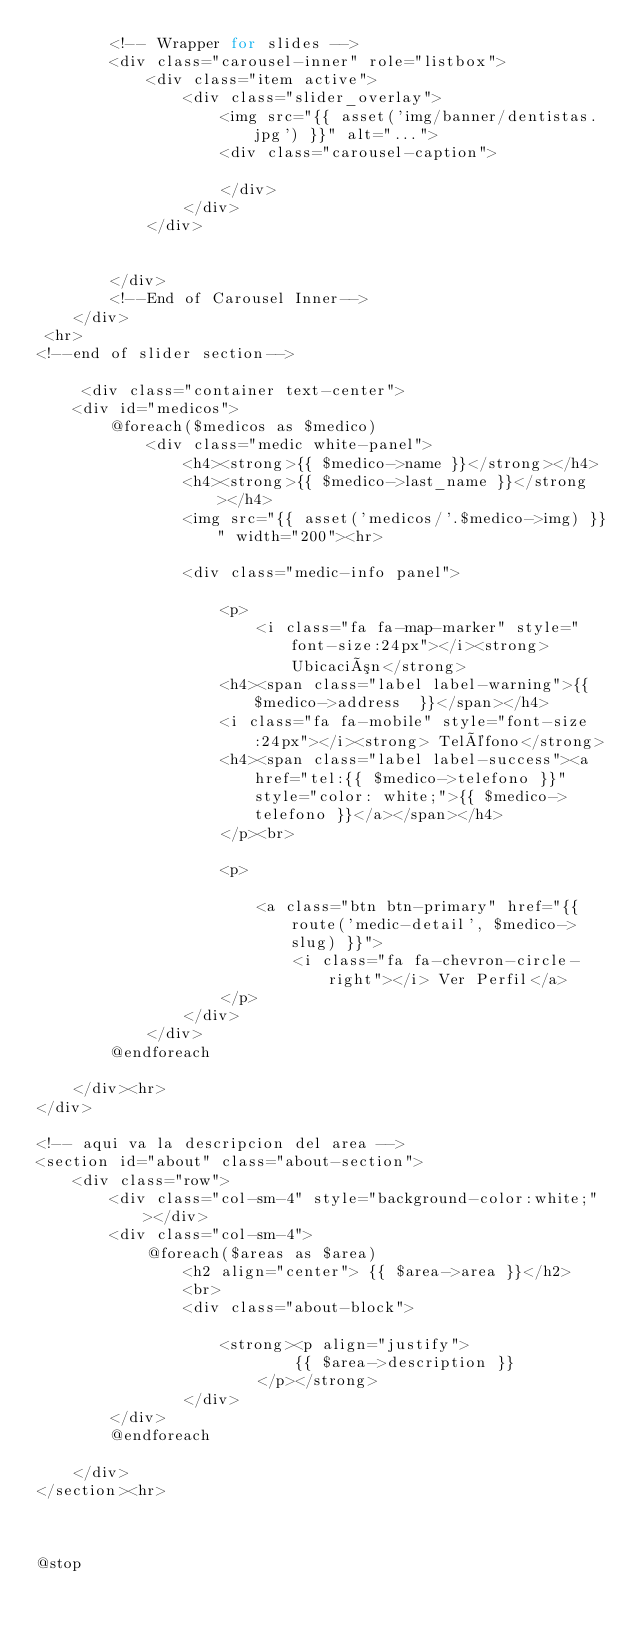<code> <loc_0><loc_0><loc_500><loc_500><_PHP_>        <!-- Wrapper for slides -->
        <div class="carousel-inner" role="listbox">
            <div class="item active">
                <div class="slider_overlay">
                    <img src="{{ asset('img/banner/dentistas.jpg') }}" alt="...">
                    <div class="carousel-caption">

                    </div>
                </div>
            </div>


        </div>
        <!--End of Carousel Inner-->
    </div>
 <hr>
<!--end of slider section-->

     <div class="container text-center">
    <div id="medicos">
        @foreach($medicos as $medico)
            <div class="medic white-panel">
                <h4><strong>{{ $medico->name }}</strong></h4>
                <h4><strong>{{ $medico->last_name }}</strong></h4>
                <img src="{{ asset('medicos/'.$medico->img) }}" width="200"><hr>

                <div class="medic-info panel">

                    <p>
                        <i class="fa fa-map-marker" style="font-size:24px"></i><strong> Ubicación</strong>
                    <h4><span class="label label-warning">{{ $medico->address  }}</span></h4>
                    <i class="fa fa-mobile" style="font-size:24px"></i><strong> Teléfono</strong>
                    <h4><span class="label label-success"><a href="tel:{{ $medico->telefono }}" style="color: white;">{{ $medico->telefono }}</a></span></h4>
                    </p><br>

                    <p>

                        <a class="btn btn-primary" href="{{ route('medic-detail', $medico->slug) }}">
                            <i class="fa fa-chevron-circle-right"></i> Ver Perfil</a>
                    </p>
                </div>
            </div>
        @endforeach

    </div><hr>
</div>

<!-- aqui va la descripcion del area -->
<section id="about" class="about-section">
    <div class="row">
        <div class="col-sm-4" style="background-color:white;"></div>
        <div class="col-sm-4">
            @foreach($areas as $area)
                <h2 align="center"> {{ $area->area }}</h2>
                <br>
                <div class="about-block">

                    <strong><p align="justify">
                            {{ $area->description }}
                        </p></strong>
                </div>
        </div>
        @endforeach

    </div>
</section><hr>



@stop
</code> 